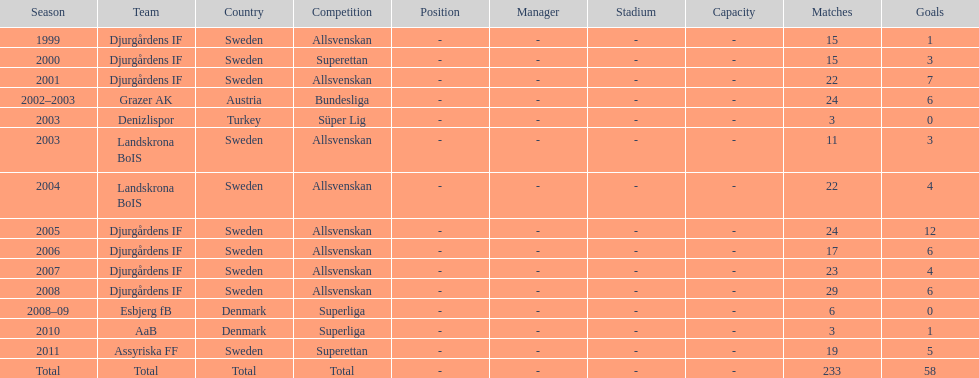How many matches did jones kusi-asare play in in his first season? 15. 